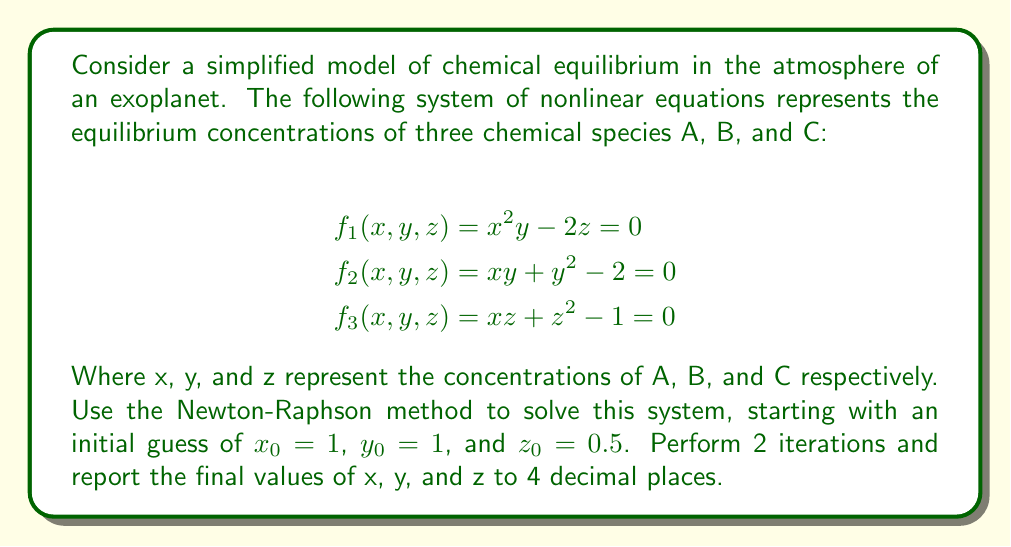Could you help me with this problem? To solve this system using the Newton-Raphson method, we follow these steps:

1) First, we need to calculate the Jacobian matrix J:

$$J = \begin{bmatrix}
\frac{\partial f_1}{\partial x} & \frac{\partial f_1}{\partial y} & \frac{\partial f_1}{\partial z} \\
\frac{\partial f_2}{\partial x} & \frac{\partial f_2}{\partial y} & \frac{\partial f_2}{\partial z} \\
\frac{\partial f_3}{\partial x} & \frac{\partial f_3}{\partial y} & \frac{\partial f_3}{\partial z}
\end{bmatrix} = \begin{bmatrix}
2xy & x^2 & -2 \\
y & x+2y & 0 \\
z & 0 & x+2z
\end{bmatrix}$$

2) The Newton-Raphson iteration is given by:

$$\begin{bmatrix} x_{n+1} \\ y_{n+1} \\ z_{n+1} \end{bmatrix} = \begin{bmatrix} x_n \\ y_n \\ z_n \end{bmatrix} - J^{-1} \begin{bmatrix} f_1(x_n, y_n, z_n) \\ f_2(x_n, y_n, z_n) \\ f_3(x_n, y_n, z_n) \end{bmatrix}$$

3) For the first iteration (n = 0):

   $x_0 = 1, y_0 = 1, z_0 = 0.5$

   $$J_0 = \begin{bmatrix}
   2 & 1 & -2 \\
   1 & 3 & 0 \\
   0.5 & 0 & 2
   \end{bmatrix}$$

   $$\begin{bmatrix} f_1 \\ f_2 \\ f_3 \end{bmatrix}_0 = \begin{bmatrix} 0 \\ 0 \\ 0.25 \end{bmatrix}$$

   Solving the system:

   $$\begin{bmatrix} x_1 \\ y_1 \\ z_1 \end{bmatrix} = \begin{bmatrix} 1 \\ 1 \\ 0.5 \end{bmatrix} - J_0^{-1} \begin{bmatrix} 0 \\ 0 \\ 0.25 \end{bmatrix} = \begin{bmatrix} 0.9688 \\ 0.9844 \\ 0.5469 \end{bmatrix}$$

4) For the second iteration (n = 1):

   $x_1 = 0.9688, y_1 = 0.9844, z_1 = 0.5469$

   $$J_1 = \begin{bmatrix}
   1.9073 & 0.9383 & -2 \\
   0.9844 & 2.9532 & 0 \\
   0.5469 & 0 & 2.0938
   \end{bmatrix}$$

   $$\begin{bmatrix} f_1 \\ f_2 \\ f_3 \end{bmatrix}_1 = \begin{bmatrix} -0.0931 \\ -0.0312 \\ 0.0312 \end{bmatrix}$$

   Solving the system:

   $$\begin{bmatrix} x_2 \\ y_2 \\ z_2 \end{bmatrix} = \begin{bmatrix} 0.9688 \\ 0.9844 \\ 0.5469 \end{bmatrix} - J_1^{-1} \begin{bmatrix} -0.0931 \\ -0.0312 \\ 0.0312 \end{bmatrix} = \begin{bmatrix} 1.0002 \\ 1.0001 \\ 0.5001 \end{bmatrix}$$
Answer: x = 1.0002, y = 1.0001, z = 0.5001 